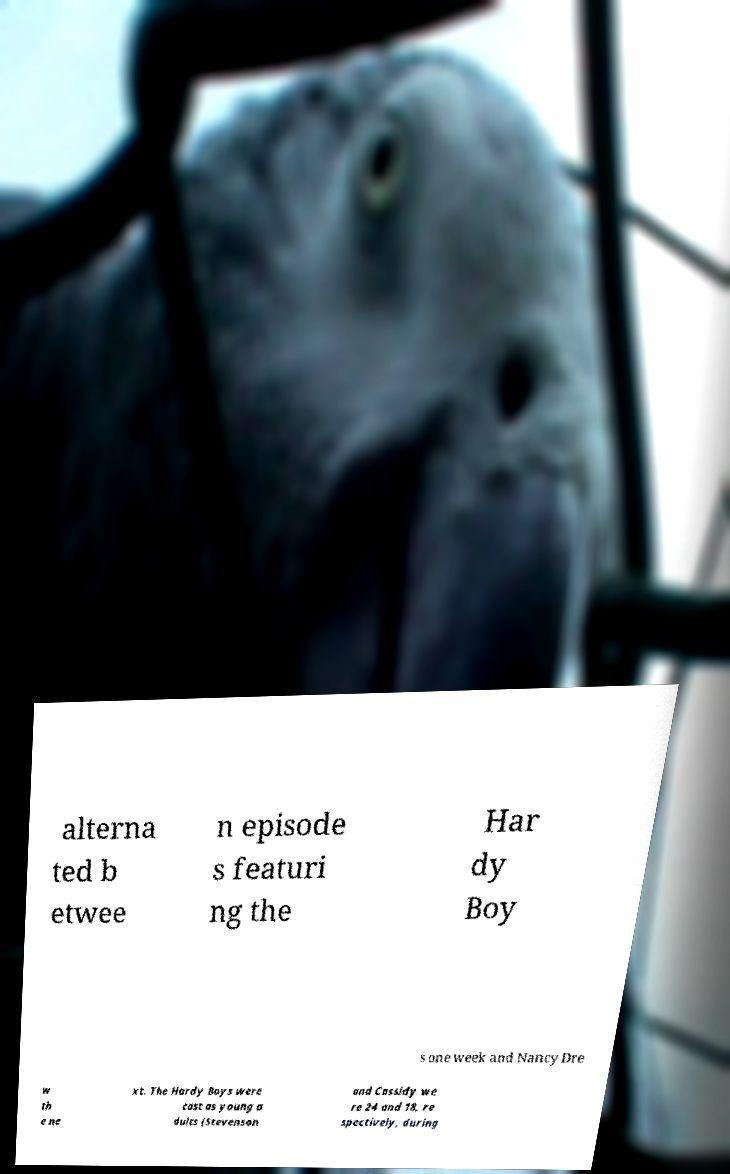Please read and relay the text visible in this image. What does it say? alterna ted b etwee n episode s featuri ng the Har dy Boy s one week and Nancy Dre w th e ne xt. The Hardy Boys were cast as young a dults (Stevenson and Cassidy we re 24 and 18, re spectively, during 